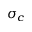Convert formula to latex. <formula><loc_0><loc_0><loc_500><loc_500>\sigma _ { c }</formula> 